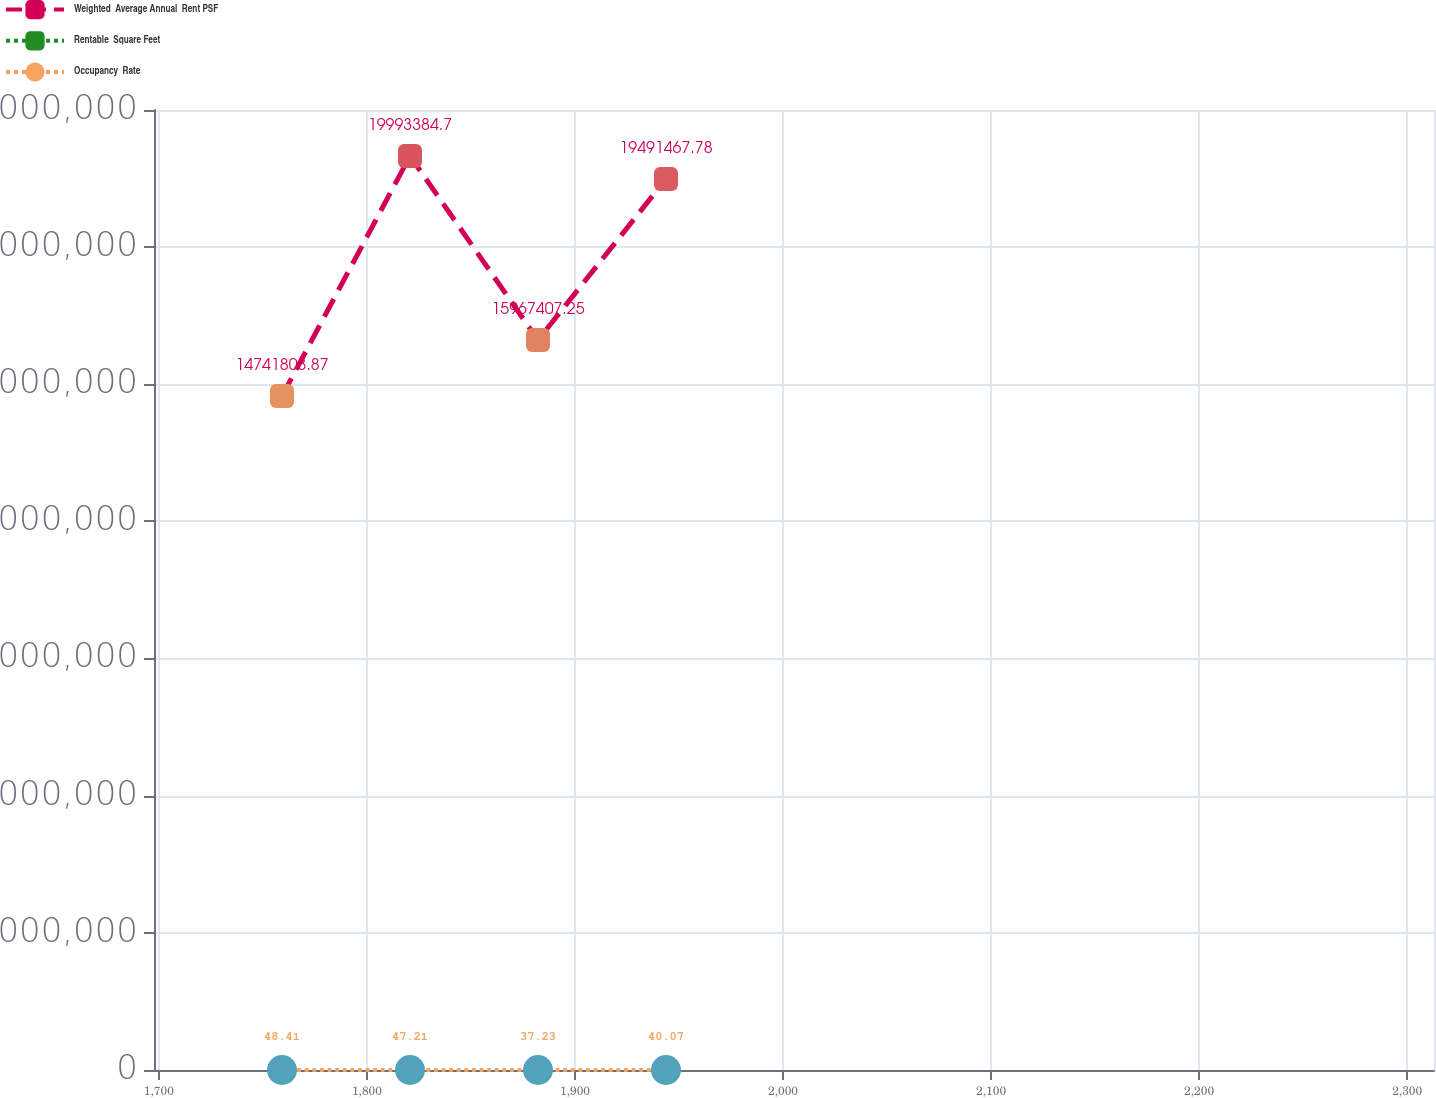Convert chart to OTSL. <chart><loc_0><loc_0><loc_500><loc_500><line_chart><ecel><fcel>Weighted  Average Annual  Rent PSF<fcel>Rentable  Square Feet<fcel>Occupancy  Rate<nl><fcel>1759.18<fcel>1.47418e+07<fcel>94.77<fcel>48.41<nl><fcel>1820.7<fcel>1.99934e+07<fcel>103.98<fcel>47.21<nl><fcel>1882.22<fcel>1.59674e+07<fcel>90.17<fcel>37.23<nl><fcel>1943.74<fcel>1.94915e+07<fcel>85.39<fcel>40.07<nl><fcel>2374.42<fcel>2.04953e+07<fcel>92.91<fcel>35.31<nl></chart> 